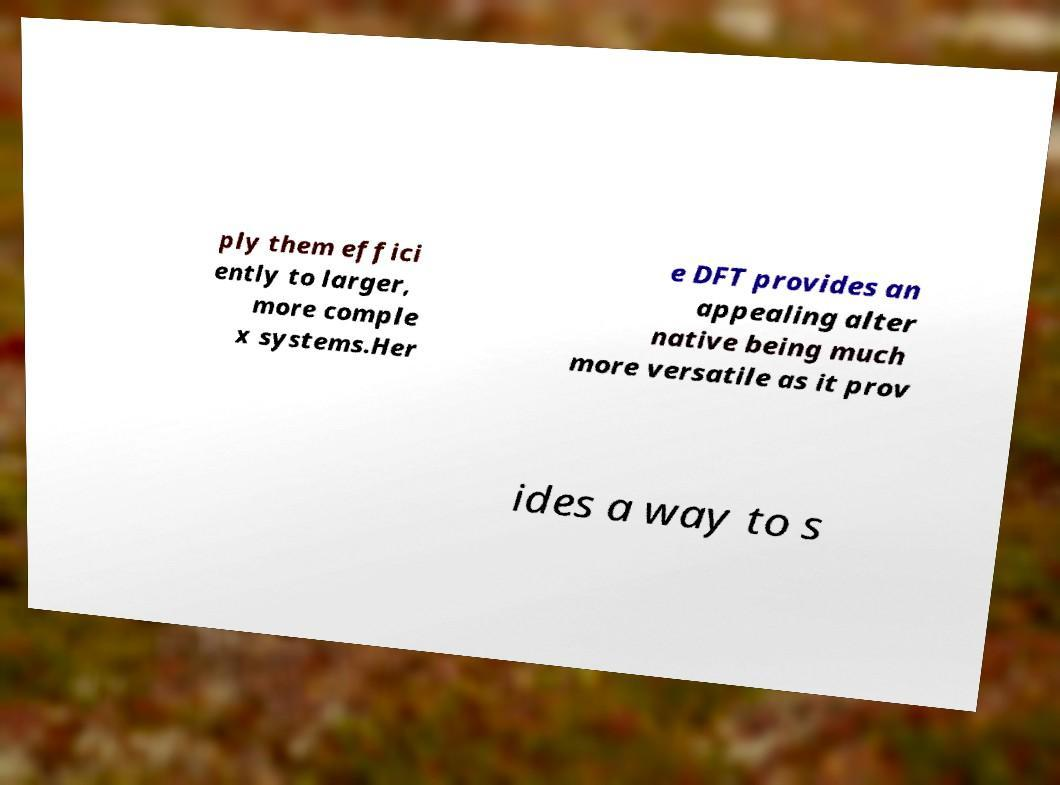Could you extract and type out the text from this image? ply them effici ently to larger, more comple x systems.Her e DFT provides an appealing alter native being much more versatile as it prov ides a way to s 